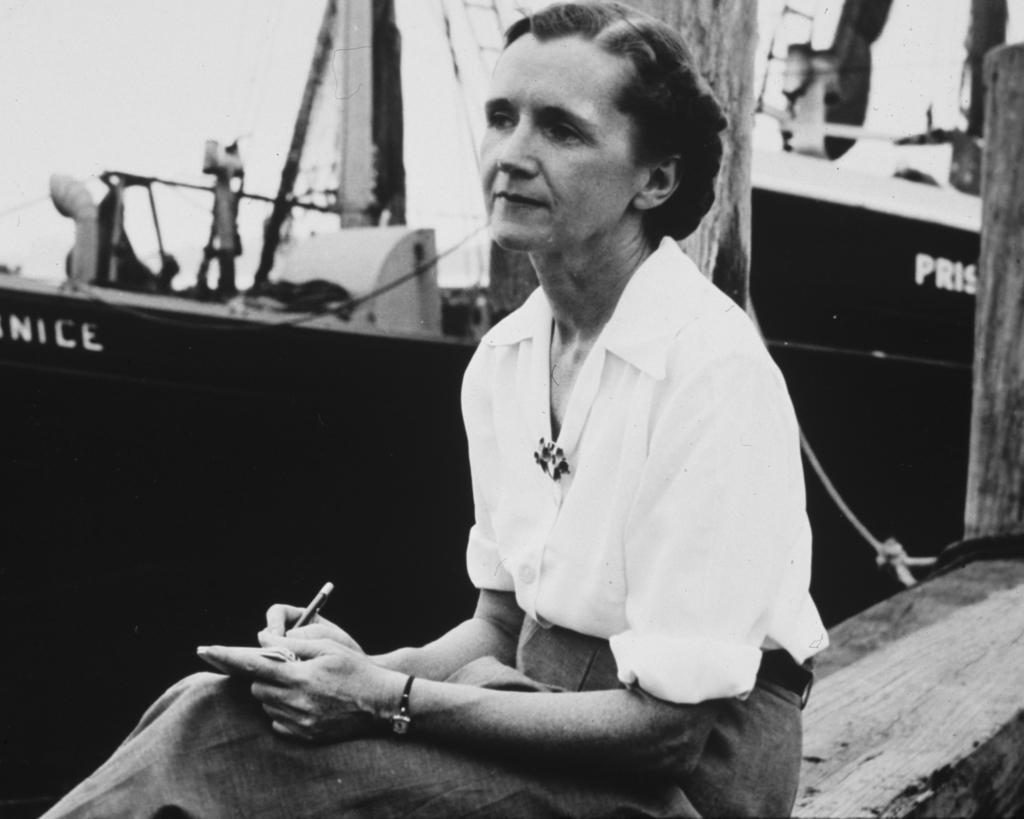Can you describe this image briefly? This is a black and white image. We can see a woman is holding a pen and an object. Behind the woman, there are wooden objects, a rope, a boat and the sky. 